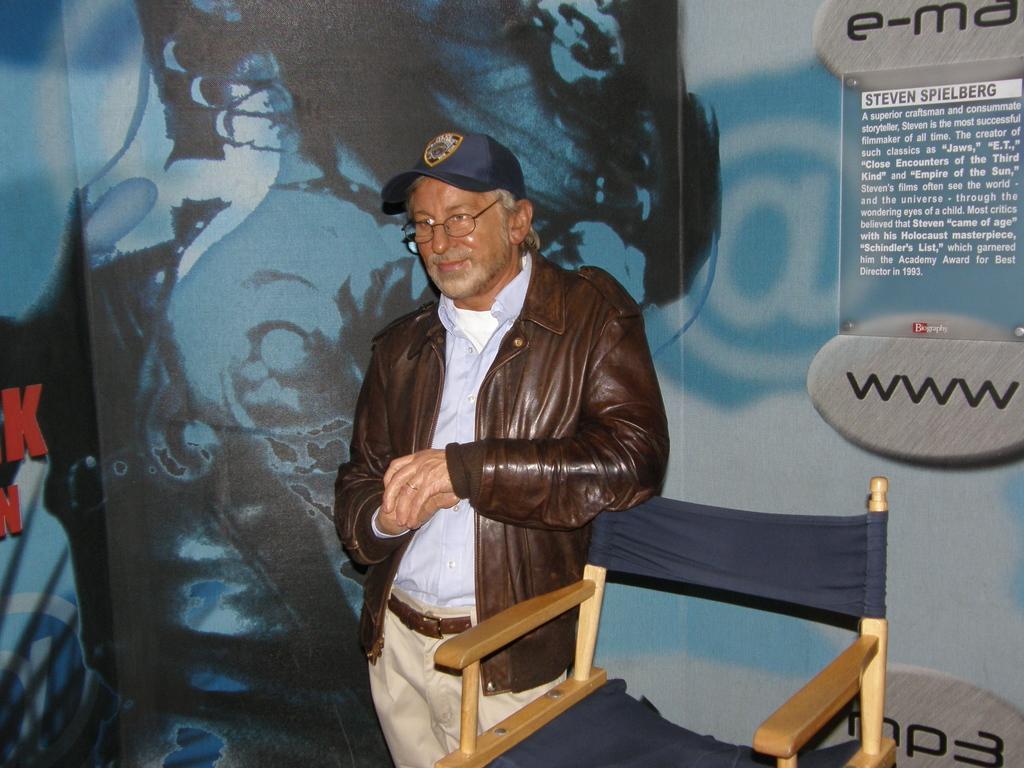Could you give a brief overview of what you see in this image? In the image I can see a chair and a person wearing blue, brown and cream colored dress is standing. In the background I can see a huge banner which is blue, black and grey in color. 